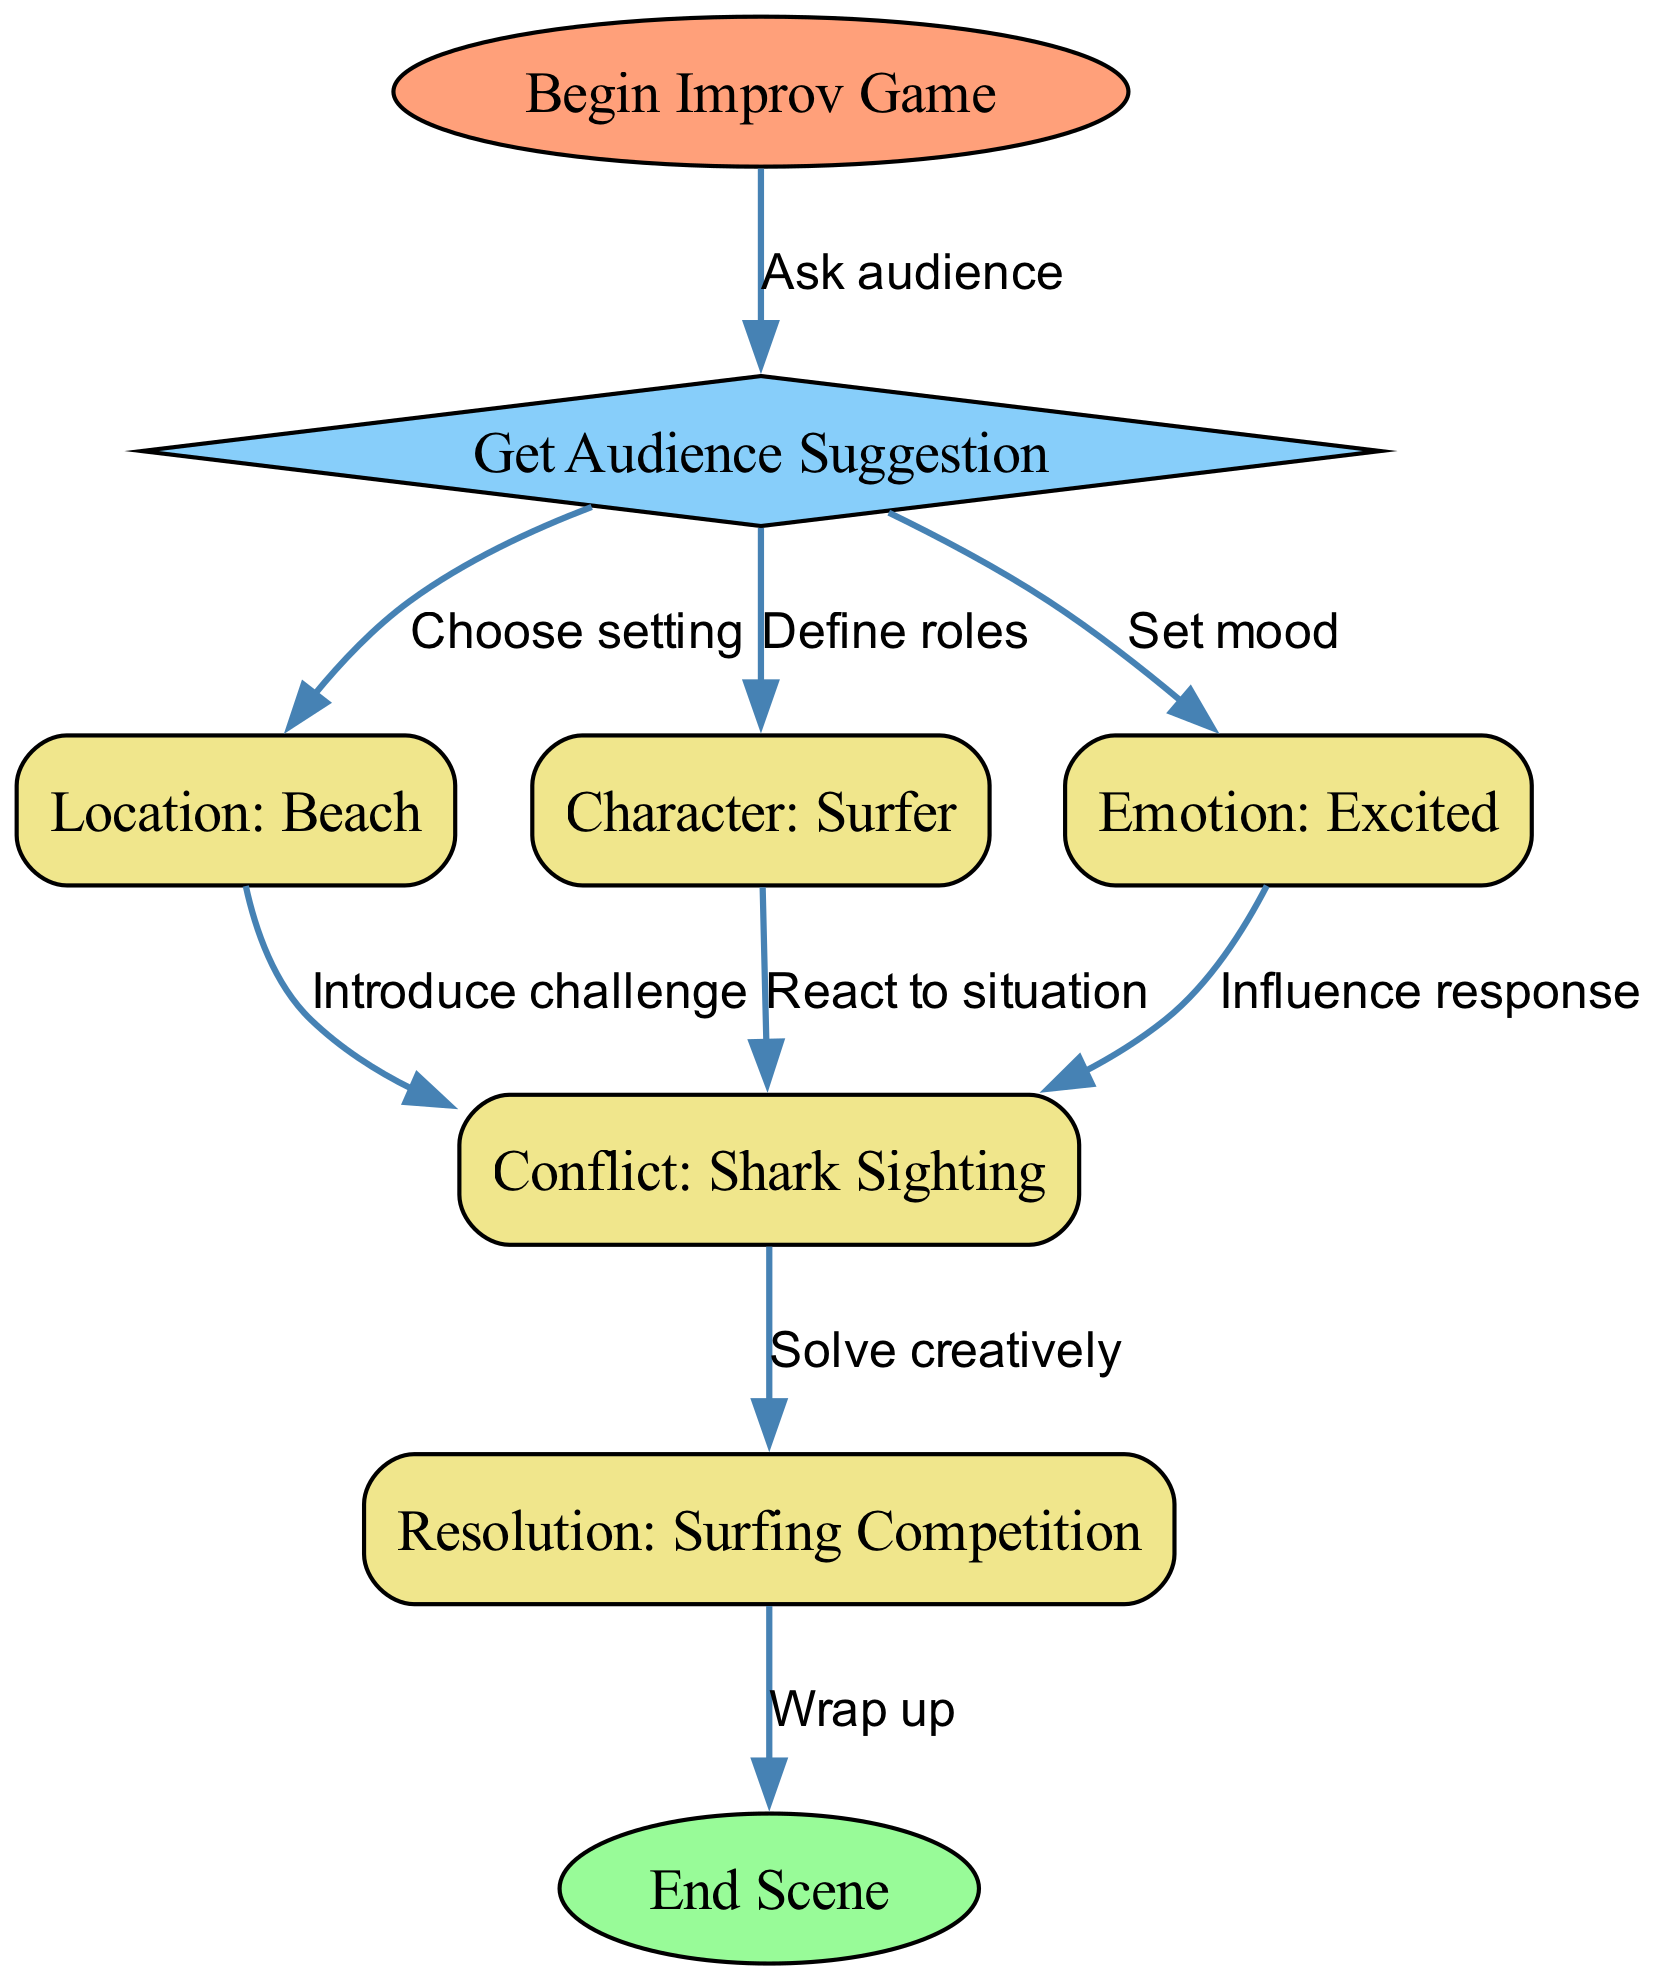What is the starting point of the diagram? The starting point of the diagram is identified as the node labeled "Begin Improv Game." This is the first node in the flow, representing the initial action that kicks off the entire decision tree.
Answer: Begin Improv Game How many nodes are in the diagram? By counting all the unique nodes listed in the data, we find that there are eight distinct nodes: Begin Improv Game, Get Audience Suggestion, Location: Beach, Character: Surfer, Emotion: Excited, Conflict: Shark Sighting, Resolution: Surfing Competition, and End Scene. Thus, the total number is eight.
Answer: Eight What is the first step after receiving an audience suggestion? After the audience suggestion, the diagram shows three initial branching options: choosing a location, defining a character, or setting an emotion. Since the prompt specifically asks for the first step after the suggestion, we consider "Choosing a location" as the first pathway in the flow.
Answer: Choose setting Which node leads to the final resolution of the scene? The node that leads to the final resolution of the scene is "Resolution: Surfing Competition." This node is connected to the previous node, "Conflict: Shark Sighting," indicating that it follows as the solution to the introduced conflict.
Answer: Resolution: Surfing Competition How many edges are connected to the "conflict" node? By examining the connections stemming from the "Conflict: Shark Sighting" node, we count three edges leading out to the "Resolution" node. Therefore, the number of edges that connect to the conflict node, indicating different possible resolutions, is three.
Answer: Three What happens after the resolution in the diagram? After the resolution labeled "Surfing Competition," the next node in the diagram is "End Scene," which indicates the conclusion of the improv game following the resolution of the conflict. This means that once the resolution is reached, the scene is wrapped up.
Answer: Wrap up What influences the response in the conflict node? The diagram indicates that the emotion node influences how characters react to the conflict. This means the emotional state selected before can affect the decision-making and actions taken in response to the conflict situation.
Answer: Influence response Which type of conflict is introduced after choosing the location? After choosing the location, the diagram specifies a "Conflict: Shark Sighting" as the challenge introduced in the scene. This specifies what the characters will face in the chosen setting.
Answer: Shark Sighting 